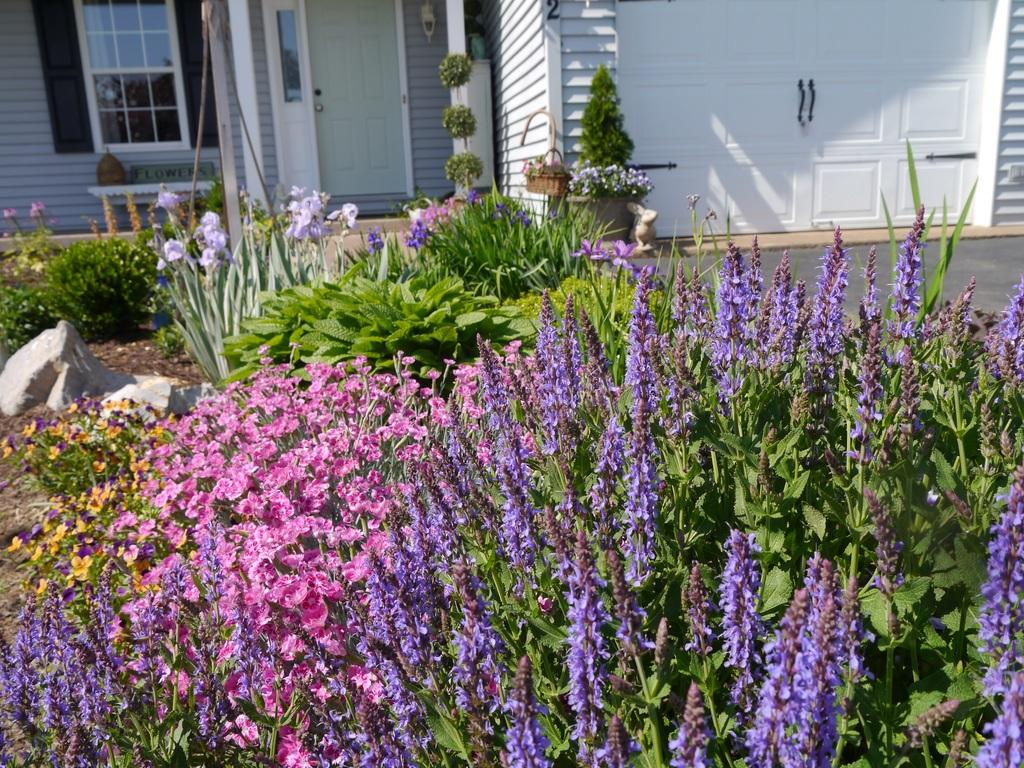What is located at the front of the image? There are flowers in the front of the image. What can be seen in the background of the image? There are plants, a building, doors, a window, and a light on the wall in the background of the image. Can you describe the building in the background? The building in the background has doors and a window. What type of light source is on the wall in the background? There is a light on the wall in the background of the image. What type of punishment is being administered to the flowers in the image? There is no punishment being administered to the flowers in the image; they are simply flowers in the front of the image. What is the title of the image? The provided facts do not mention a title for the image. 